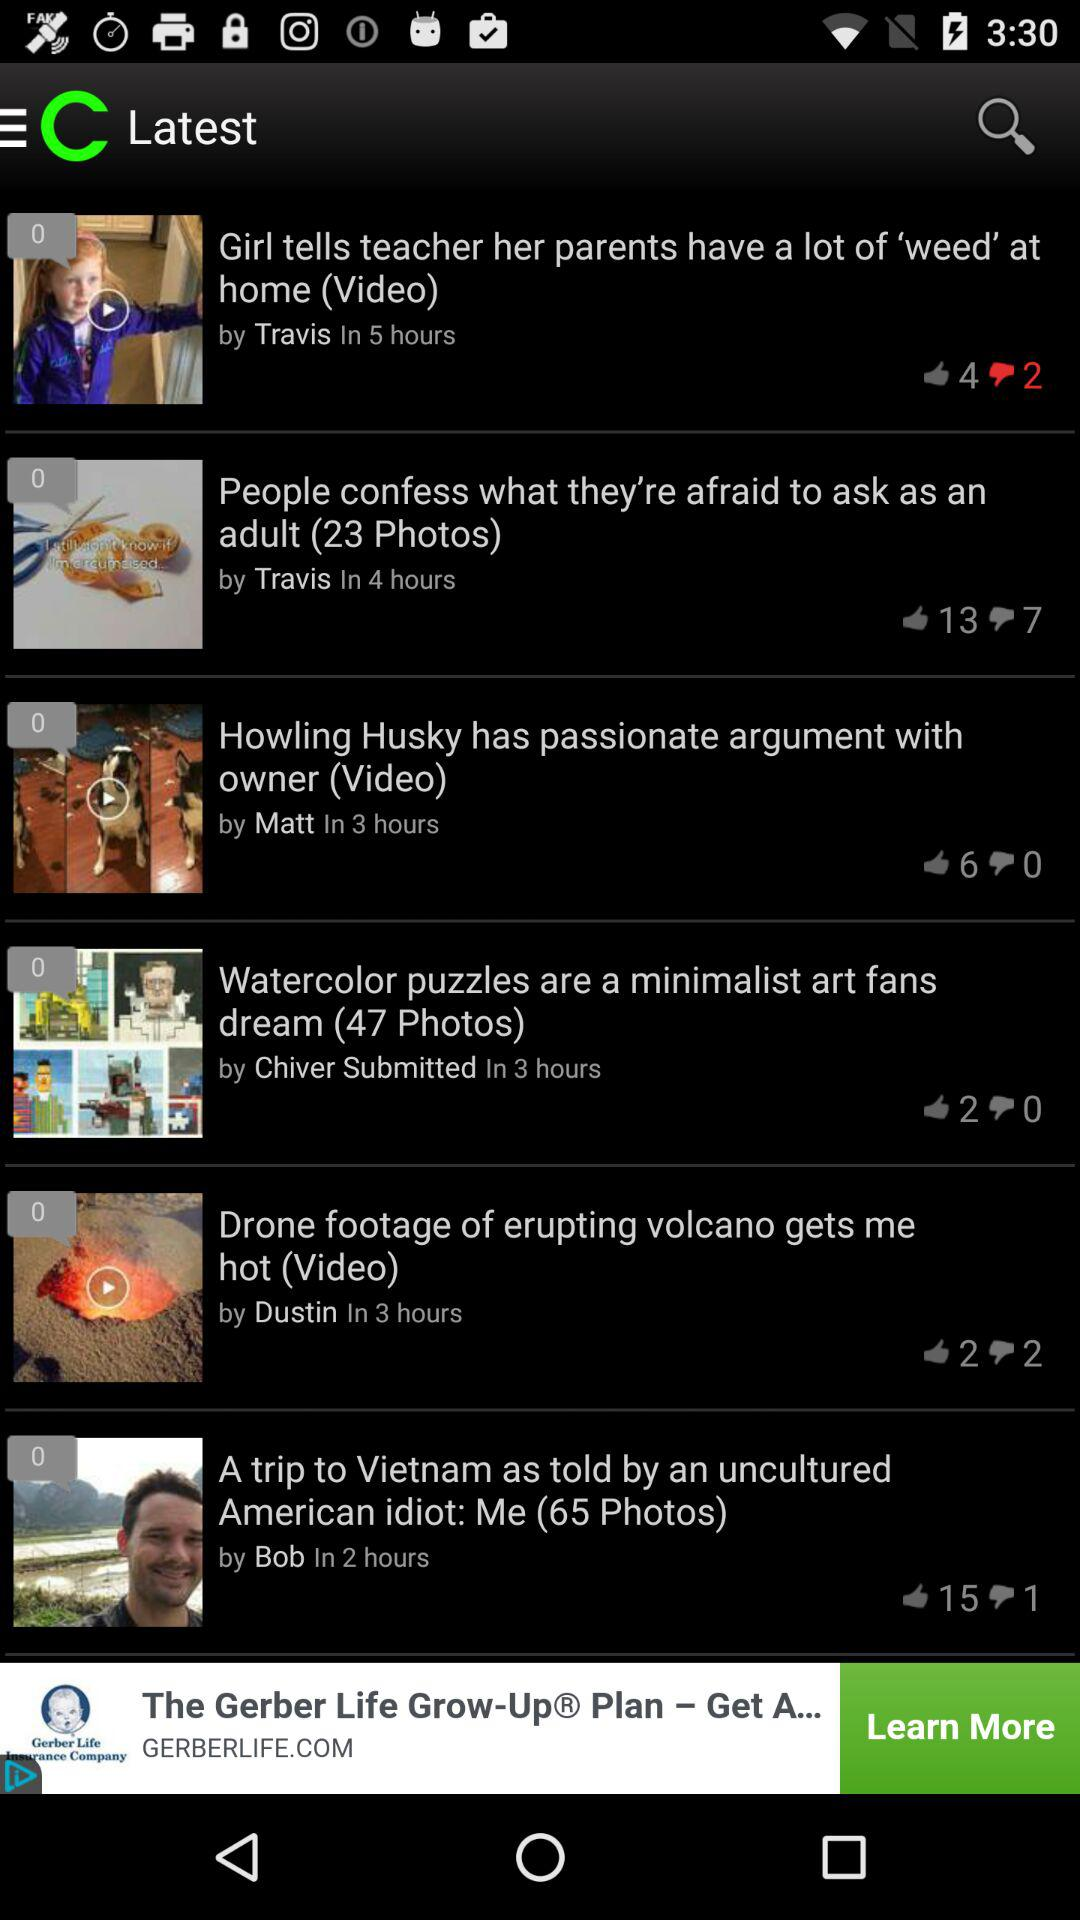How many dislikes did "People confess what they're afraid to ask as an adult" get? "People confess what they're afraid to ask as an adult" got 7 dislikes. 